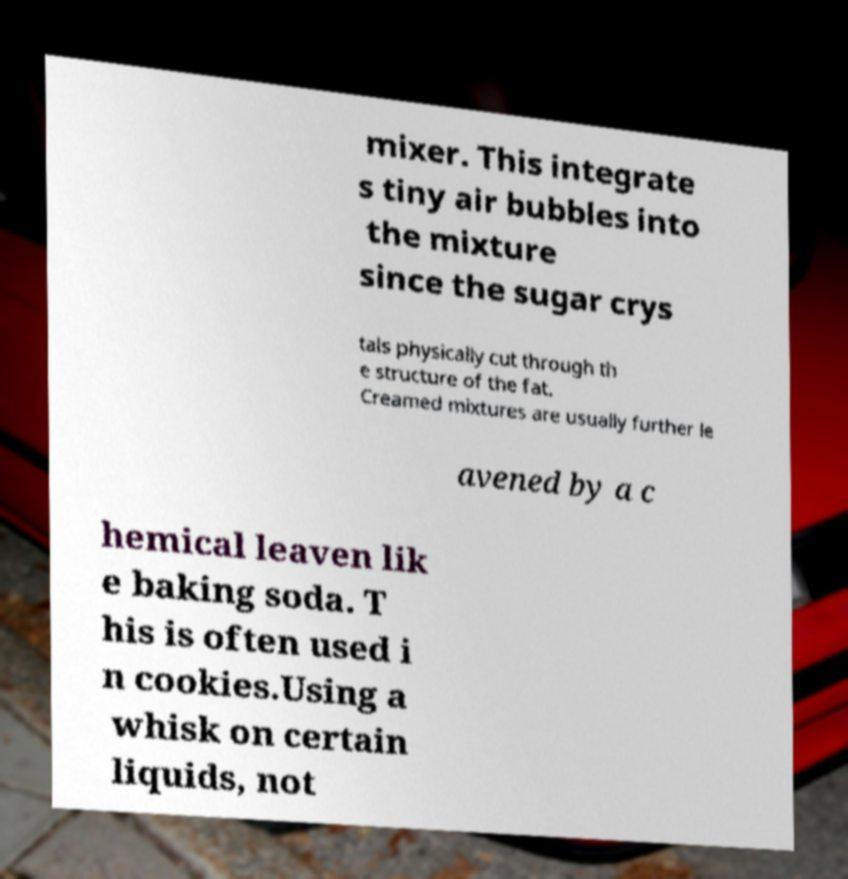I need the written content from this picture converted into text. Can you do that? mixer. This integrate s tiny air bubbles into the mixture since the sugar crys tals physically cut through th e structure of the fat. Creamed mixtures are usually further le avened by a c hemical leaven lik e baking soda. T his is often used i n cookies.Using a whisk on certain liquids, not 